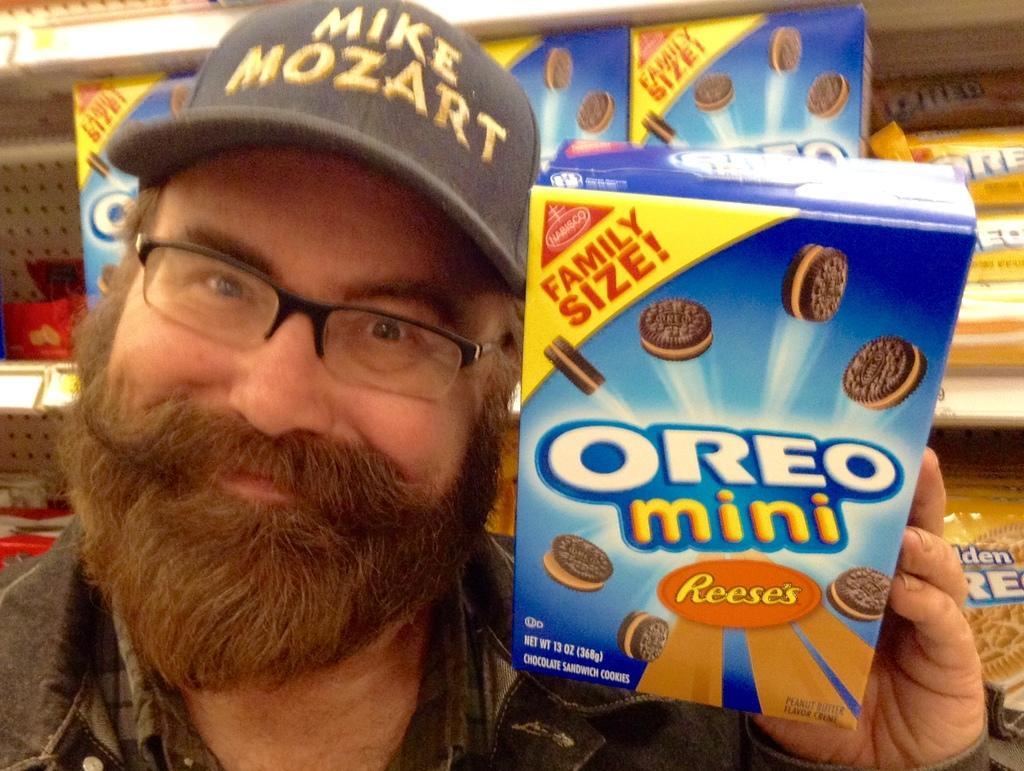In one or two sentences, can you explain what this image depicts? In this image we can see a person wearing spectacles, cap and jacket is smiling and holding a blue color box in his hands. In the background, we can see a few more boxes and packets are kept on the shelves. 